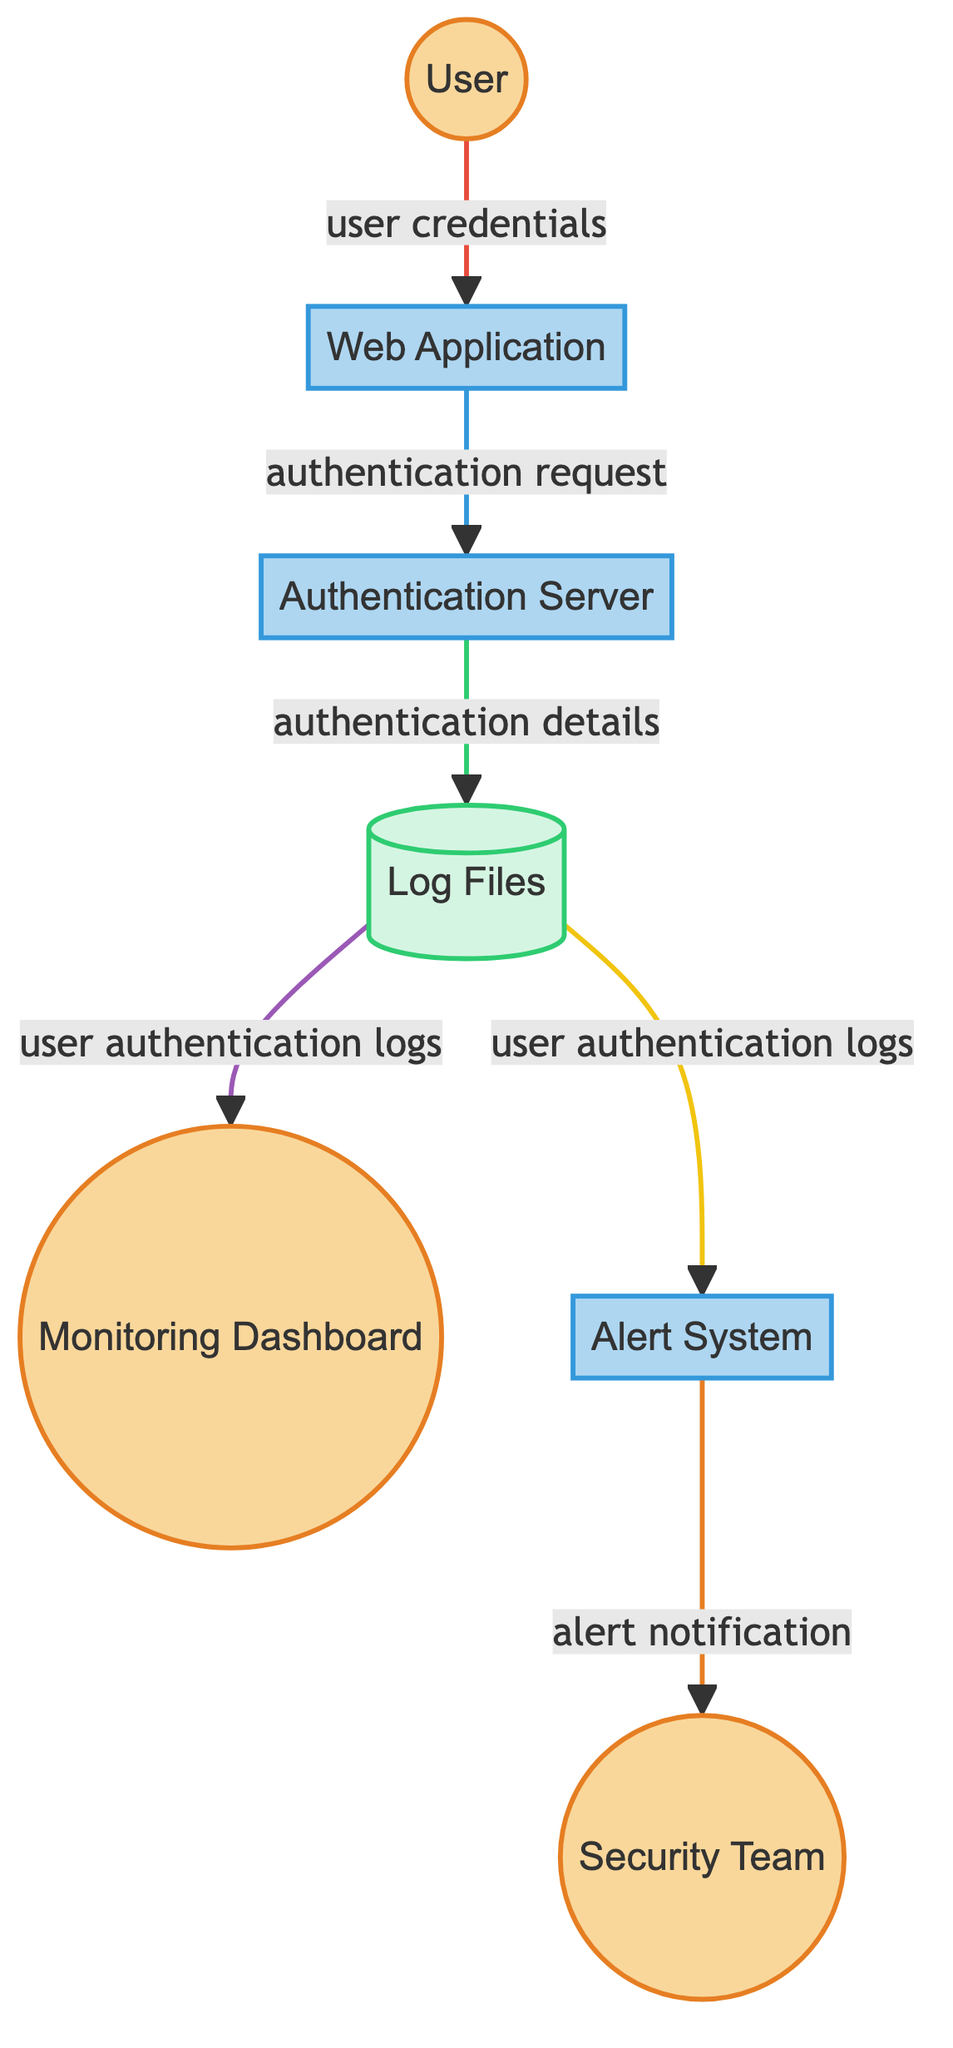What is the total number of external entities in the diagram? The diagram contains three external entities: User, Monitoring Dashboard, and Security Team.
Answer: 3 What type of entity is the Authentication Server? In the diagram, the Authentication Server is categorized as a process.
Answer: process Which entity sends the alert notification? The alert notification is sent by the Alert System to the Security Team.
Answer: Alert System How many data flows are there in the diagram? By reviewing the connections from one entity to another in the diagram, we find five distinct data flows: from User to Web Application, Web Application to Authentication Server, Authentication Server to Log Files, Log Files to Monitoring Dashboard, and Log Files to Alert System.
Answer: 6 What data is stored in the Log Files? The Log Files contain timestamp, username, IP address, and authentication status.
Answer: timestamp, username, IP address, authentication status Which entity does the User interact with first? The User first interacts with the Web Application by submitting user credentials.
Answer: Web Application What triggers an alert in the system? The Alert System raises an alert when suspicious activities or potential security threats are detected in the logs.
Answer: Suspicious activities Which entity accesses the user authentication logs for review? The Monitoring Dashboard accesses the user authentication logs for review.
Answer: Monitoring Dashboard What type of entity is the Log Files categorized as? The Log Files are categorized as a data store in the diagram.
Answer: data store 